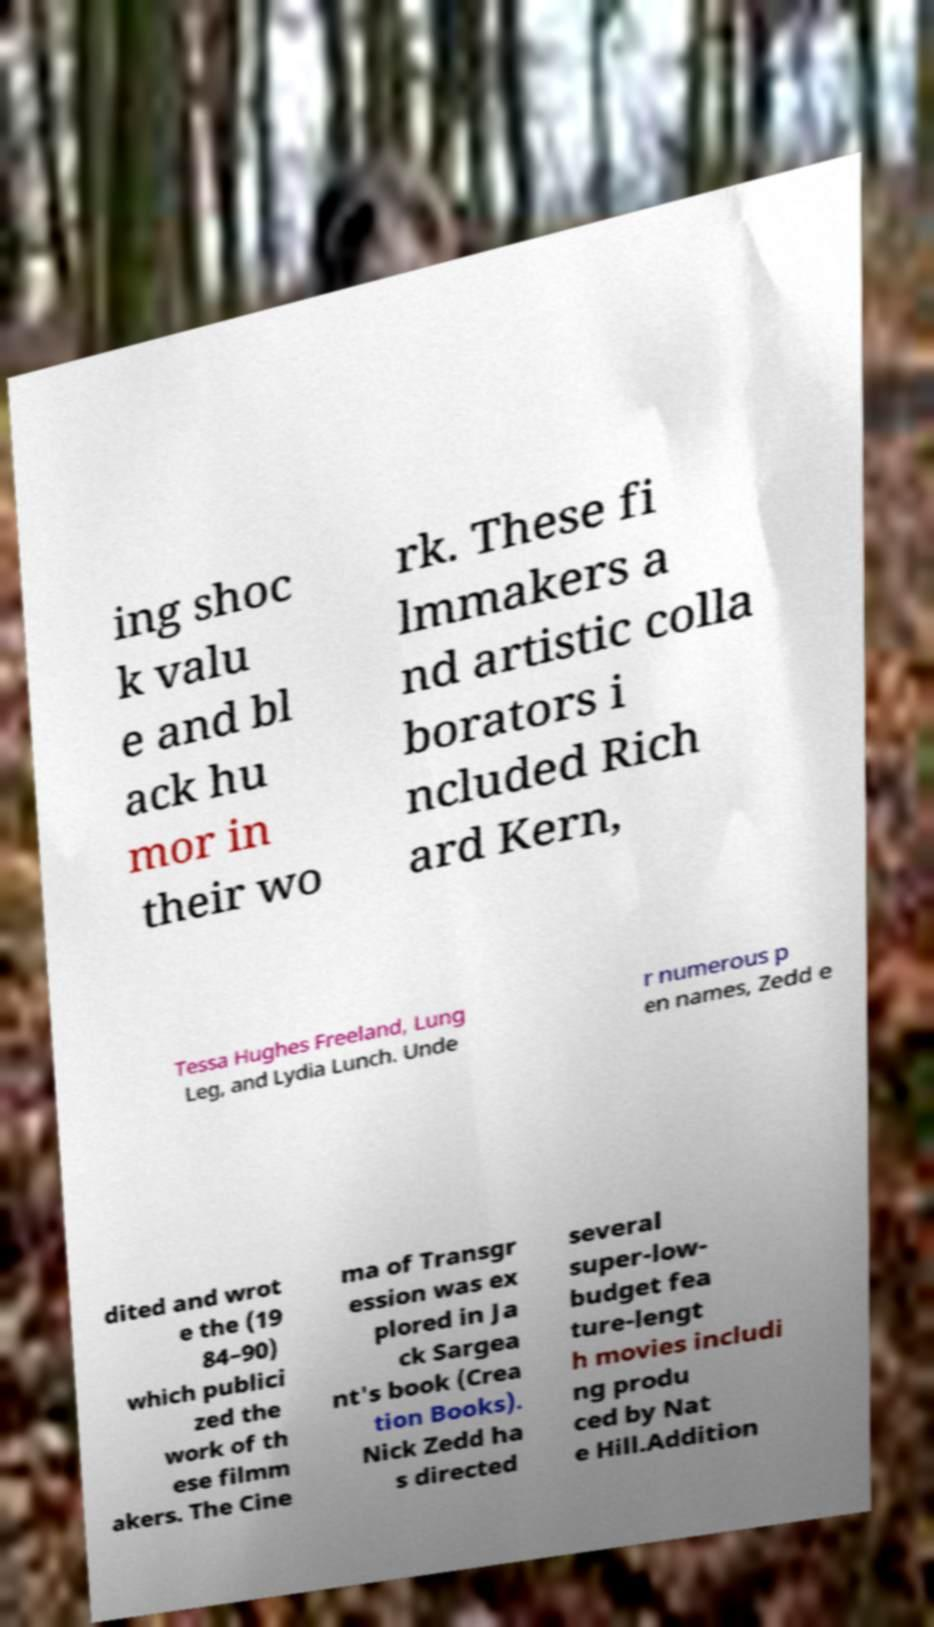There's text embedded in this image that I need extracted. Can you transcribe it verbatim? ing shoc k valu e and bl ack hu mor in their wo rk. These fi lmmakers a nd artistic colla borators i ncluded Rich ard Kern, Tessa Hughes Freeland, Lung Leg, and Lydia Lunch. Unde r numerous p en names, Zedd e dited and wrot e the (19 84–90) which publici zed the work of th ese filmm akers. The Cine ma of Transgr ession was ex plored in Ja ck Sargea nt's book (Crea tion Books). Nick Zedd ha s directed several super-low- budget fea ture-lengt h movies includi ng produ ced by Nat e Hill.Addition 